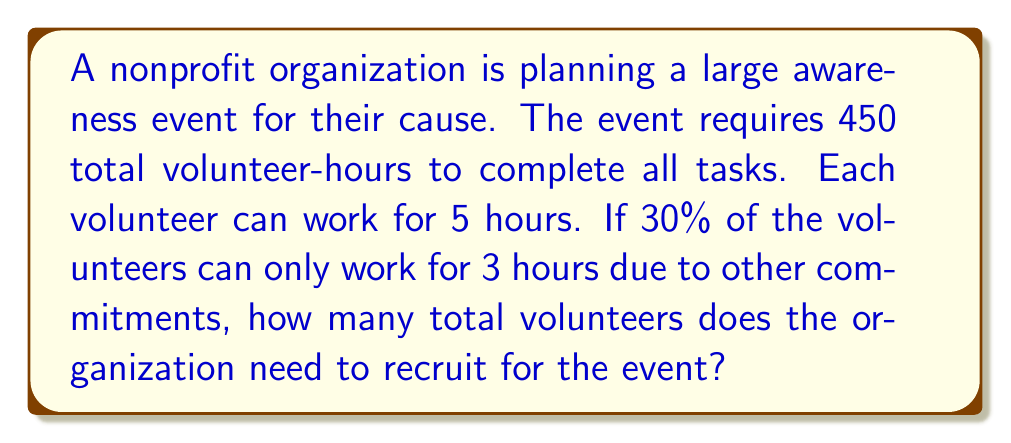Provide a solution to this math problem. Let's approach this step-by-step:

1) First, let's define our variables:
   $x$ = number of volunteers who can work 5 hours
   $y$ = number of volunteers who can only work 3 hours

2) We know that $y$ is 30% of the total volunteers, so:
   $y = 0.3(x + y)$

3) The total volunteer-hours needed is 450. We can express this as an equation:
   $5x + 3y = 450$

4) From step 2, we can express $y$ in terms of $x$:
   $y = \frac{0.3x}{0.7} = \frac{3x}{7}$

5) Substitute this into the equation from step 3:
   $5x + 3(\frac{3x}{7}) = 450$

6) Simplify:
   $5x + \frac{9x}{7} = 450$
   $\frac{35x}{7} + \frac{9x}{7} = 450$
   $\frac{44x}{7} = 450$

7) Solve for $x$:
   $x = 450 * \frac{7}{44} = 71.59$

8) Round up to 72 as we need whole numbers of volunteers.

9) Calculate $y$:
   $y = \frac{3 * 72}{7} = 30.86$, round up to 31

10) Total number of volunteers: $72 + 31 = 103$
Answer: The organization needs to recruit 103 volunteers for the event. 